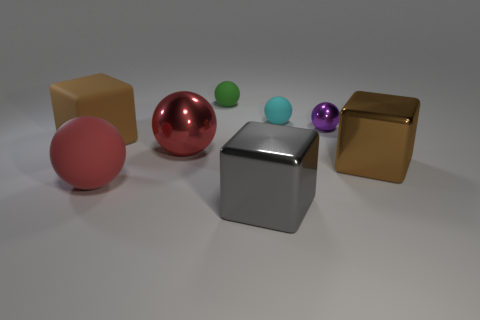Does the ball behind the cyan matte thing have the same size as the purple metallic thing?
Your answer should be compact. Yes. Are there more red spheres than big red shiny balls?
Provide a succinct answer. Yes. How many large things are either yellow spheres or red rubber things?
Offer a terse response. 1. What number of other things are the same color as the large metal sphere?
Give a very brief answer. 1. What number of small cyan things have the same material as the large gray object?
Give a very brief answer. 0. There is a big thing that is behind the red metallic object; is it the same color as the large metal sphere?
Give a very brief answer. No. How many gray objects are tiny spheres or large metal cubes?
Provide a short and direct response. 1. Is there any other thing that is the same material as the cyan ball?
Offer a very short reply. Yes. Does the brown block to the left of the green sphere have the same material as the large gray block?
Provide a short and direct response. No. What number of objects are big brown blocks or small spheres that are to the right of the cyan thing?
Ensure brevity in your answer.  3. 